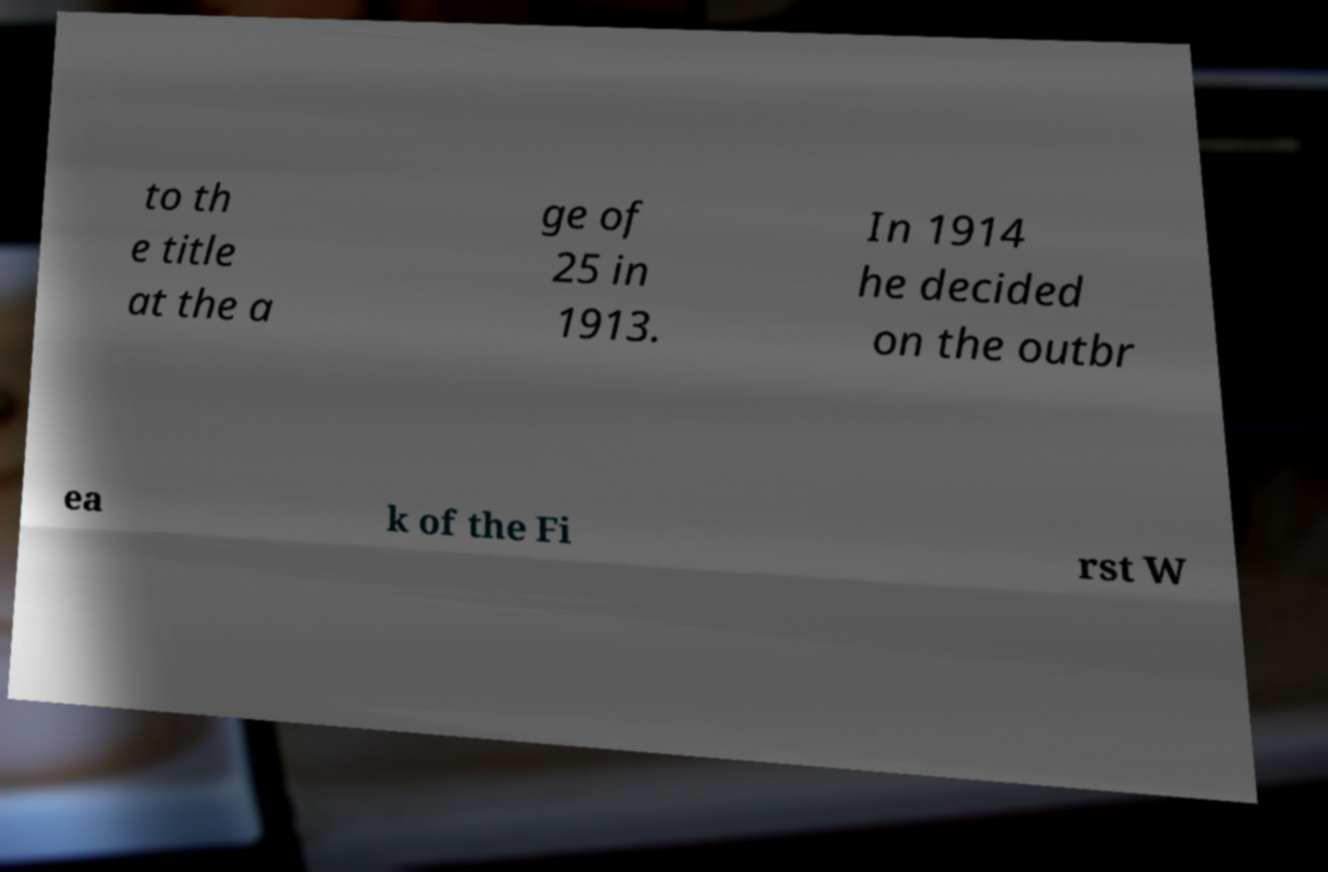Can you read and provide the text displayed in the image?This photo seems to have some interesting text. Can you extract and type it out for me? to th e title at the a ge of 25 in 1913. In 1914 he decided on the outbr ea k of the Fi rst W 